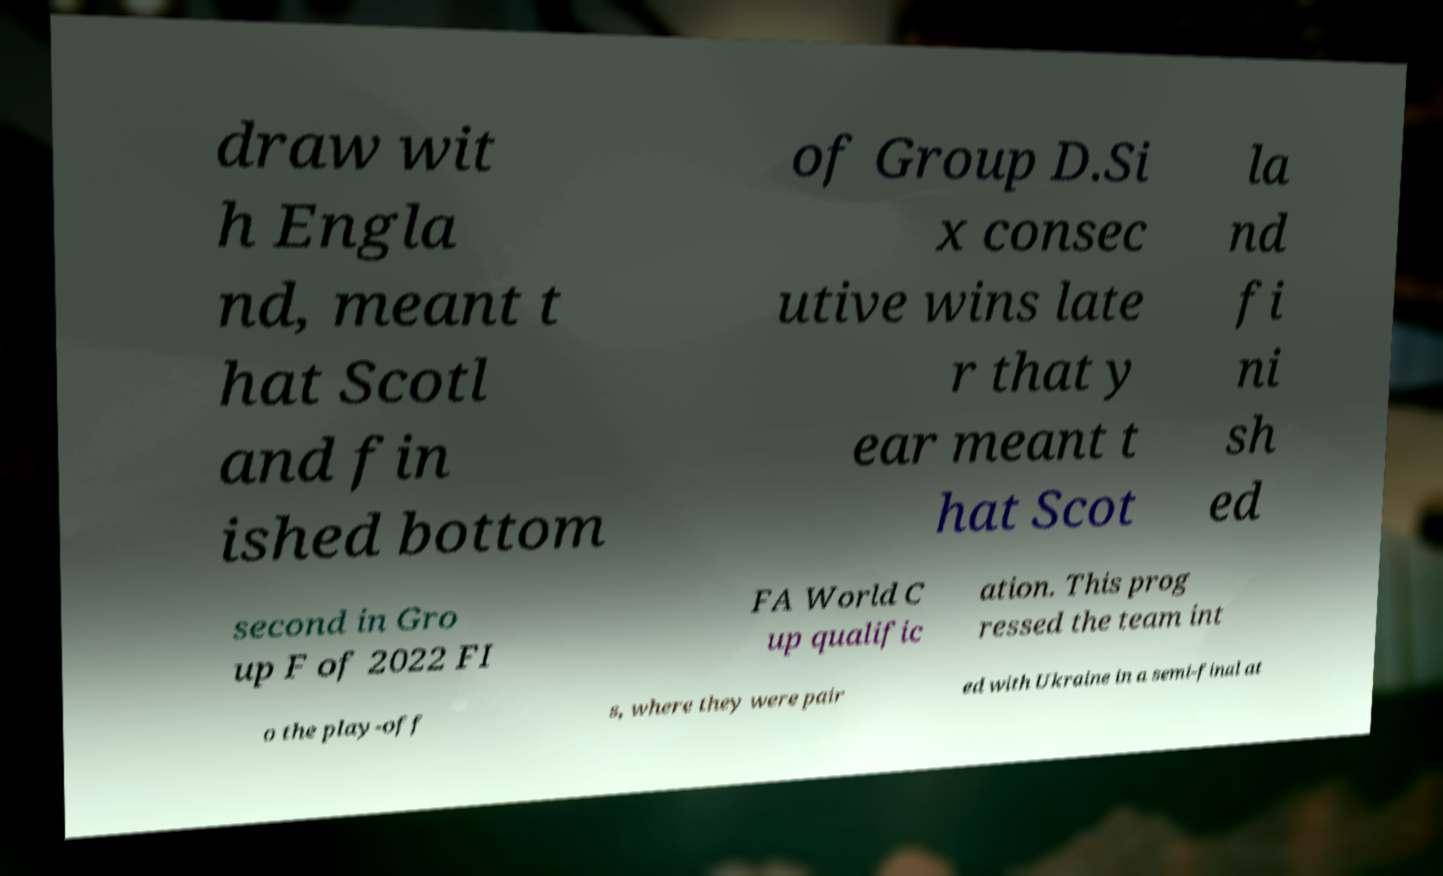Can you accurately transcribe the text from the provided image for me? draw wit h Engla nd, meant t hat Scotl and fin ished bottom of Group D.Si x consec utive wins late r that y ear meant t hat Scot la nd fi ni sh ed second in Gro up F of 2022 FI FA World C up qualific ation. This prog ressed the team int o the play-off s, where they were pair ed with Ukraine in a semi-final at 